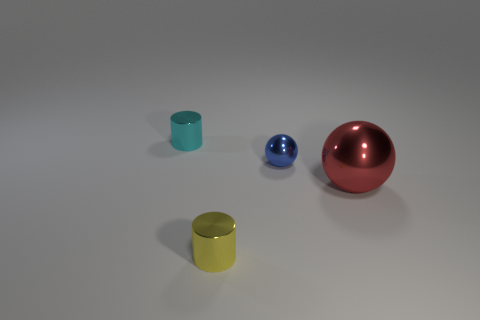There is a blue object in front of the cylinder behind the yellow shiny object; what is it made of?
Make the answer very short. Metal. There is a blue thing that is made of the same material as the small yellow cylinder; what is its shape?
Offer a very short reply. Sphere. How big is the shiny ball that is in front of the blue ball?
Keep it short and to the point. Large. Is the number of balls that are in front of the big red metallic object the same as the number of large red metallic objects behind the cyan shiny thing?
Offer a very short reply. Yes. There is a tiny cylinder behind the small metal cylinder right of the shiny cylinder that is behind the blue object; what is its color?
Offer a very short reply. Cyan. What number of metal things are both left of the big red metallic sphere and behind the tiny yellow cylinder?
Keep it short and to the point. 2. What size is the other metal thing that is the same shape as the yellow thing?
Ensure brevity in your answer.  Small. Are there any large balls on the right side of the yellow cylinder?
Provide a short and direct response. Yes. Are there the same number of metallic balls that are in front of the small yellow metal thing and big yellow cubes?
Offer a terse response. Yes. Are there any tiny cylinders left of the tiny metal thing left of the metal thing in front of the red shiny ball?
Ensure brevity in your answer.  No. 